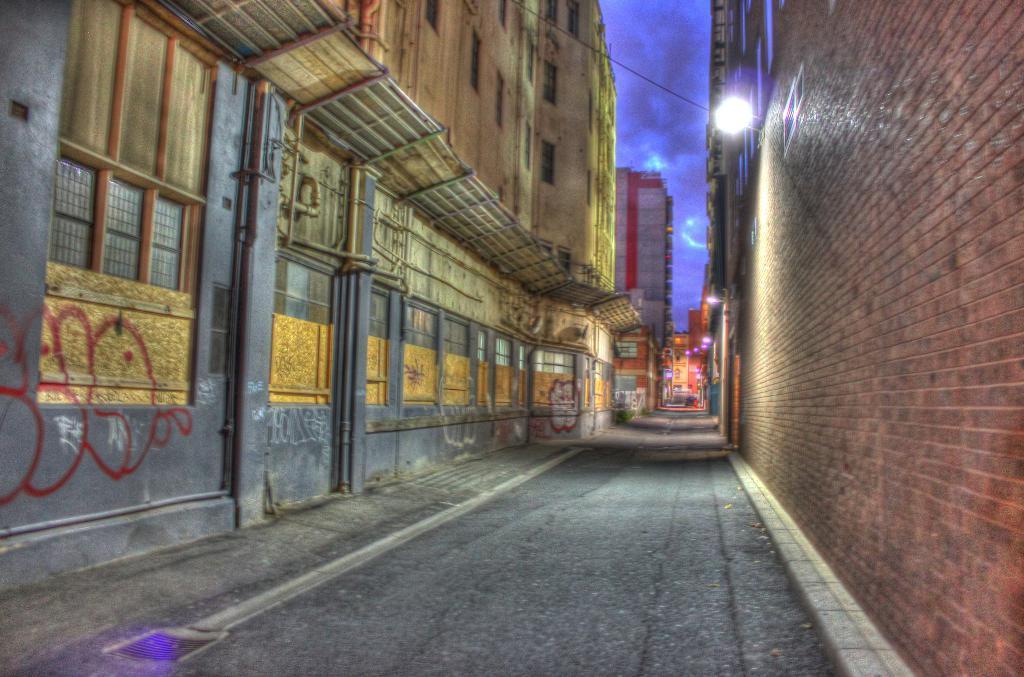Please provide a concise description of this image. In this image we can see many buildings. There is a lamp on the wall and a cable is connected to it. There is a cloudy sky in the image. 